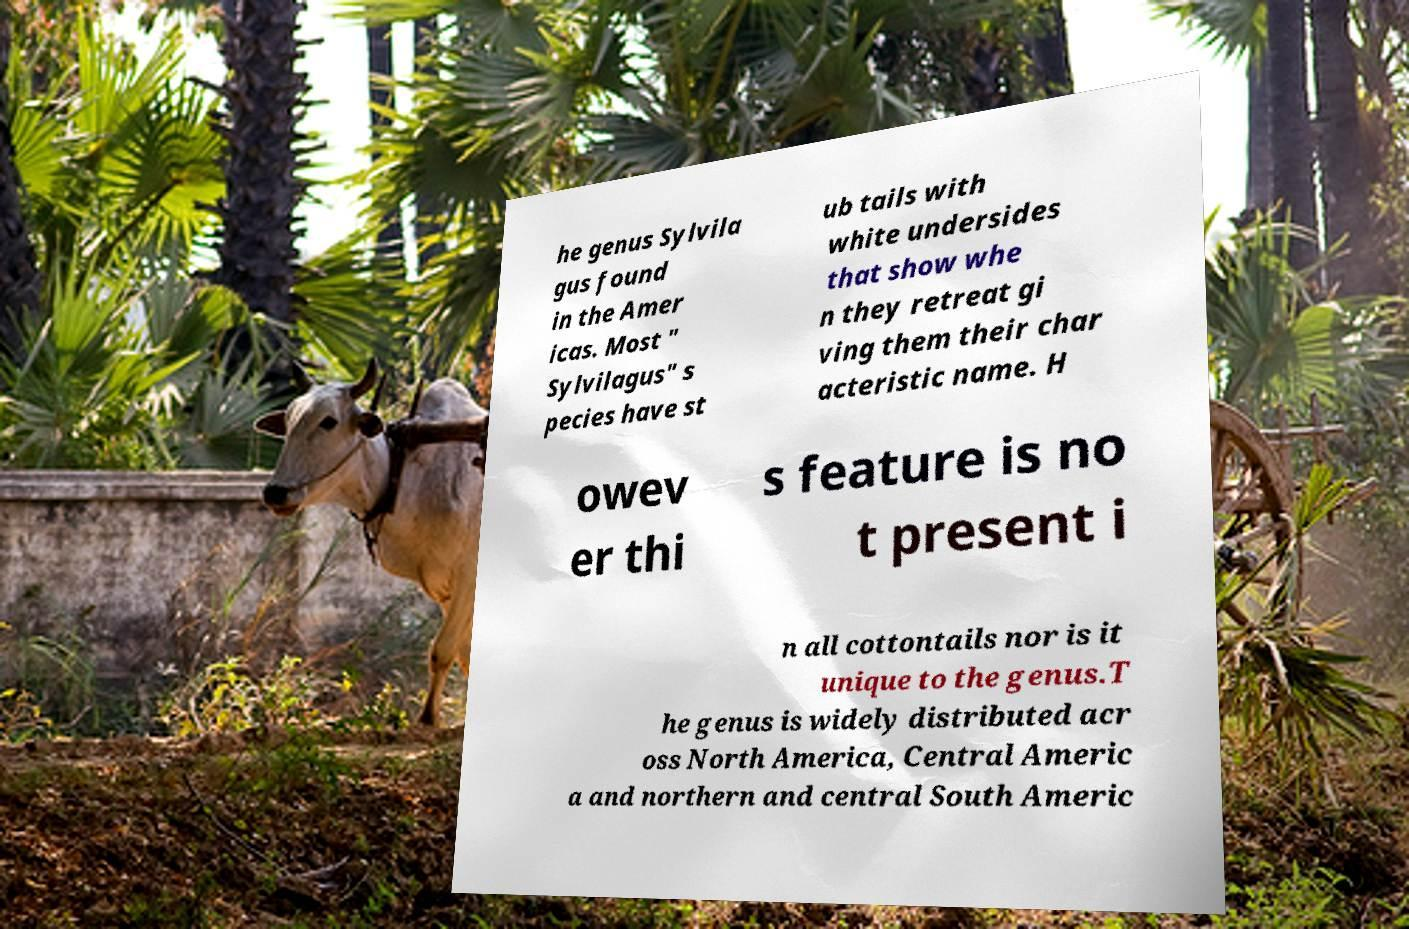Please read and relay the text visible in this image. What does it say? he genus Sylvila gus found in the Amer icas. Most " Sylvilagus" s pecies have st ub tails with white undersides that show whe n they retreat gi ving them their char acteristic name. H owev er thi s feature is no t present i n all cottontails nor is it unique to the genus.T he genus is widely distributed acr oss North America, Central Americ a and northern and central South Americ 